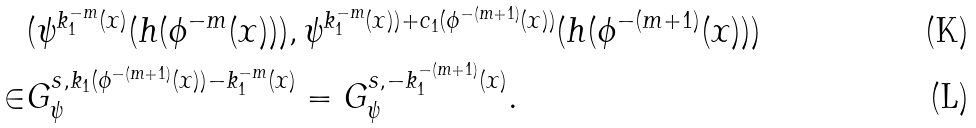<formula> <loc_0><loc_0><loc_500><loc_500>& ( \psi ^ { k _ { 1 } ^ { - m } ( x ) } ( h ( \phi ^ { - m } ( x ) ) ) , \psi ^ { k _ { 1 } ^ { - m } ( x ) ) + c _ { 1 } ( \phi ^ { - ( m + 1 ) } ( x ) ) } ( h ( \phi ^ { - ( m + 1 ) } ( x ) ) ) \\ \in & G _ { \psi } ^ { s , k _ { 1 } ( \phi ^ { - ( m + 1 ) } ( x ) ) - k _ { 1 } ^ { - m } ( x ) } = G _ { \psi } ^ { s , - k _ { 1 } ^ { - ( m + 1 ) } ( x ) } .</formula> 